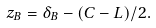<formula> <loc_0><loc_0><loc_500><loc_500>z _ { B } = \delta _ { B } - ( C - L ) / 2 .</formula> 